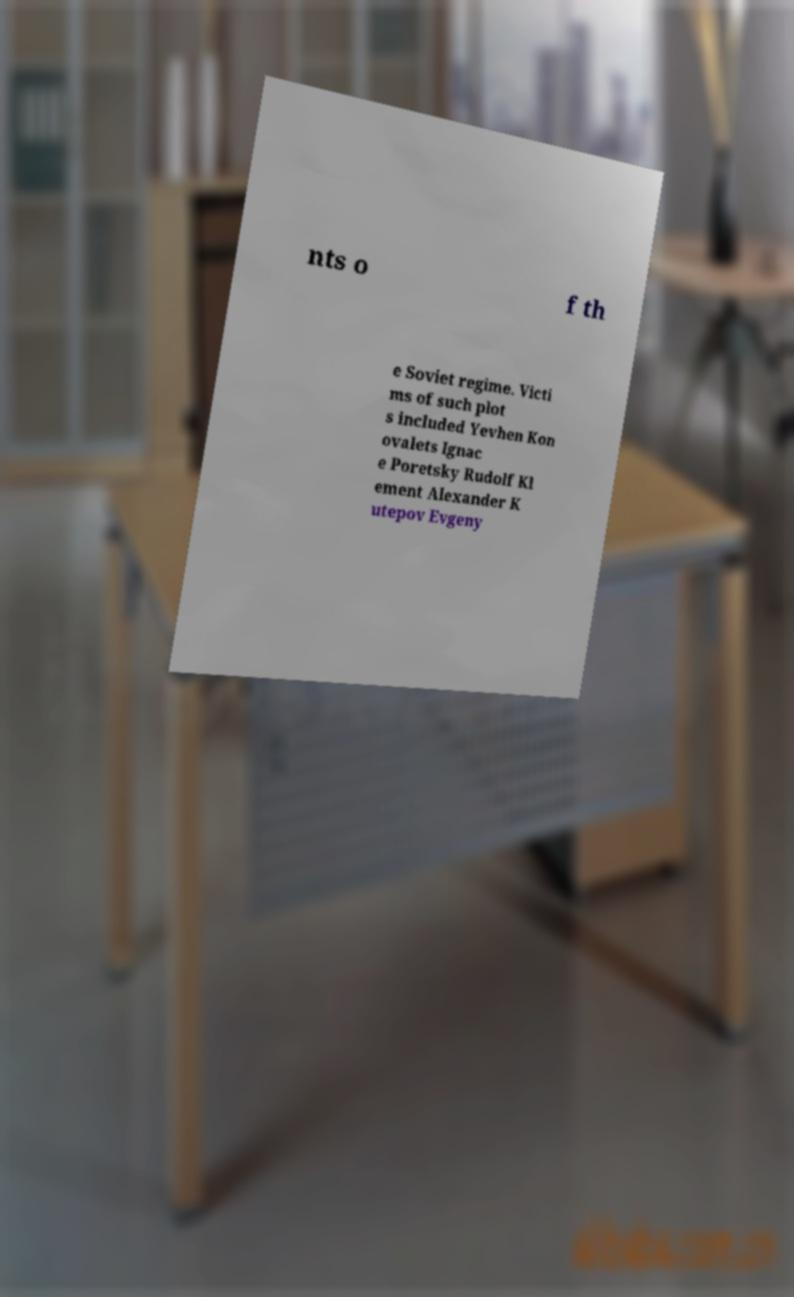Can you accurately transcribe the text from the provided image for me? nts o f th e Soviet regime. Victi ms of such plot s included Yevhen Kon ovalets Ignac e Poretsky Rudolf Kl ement Alexander K utepov Evgeny 